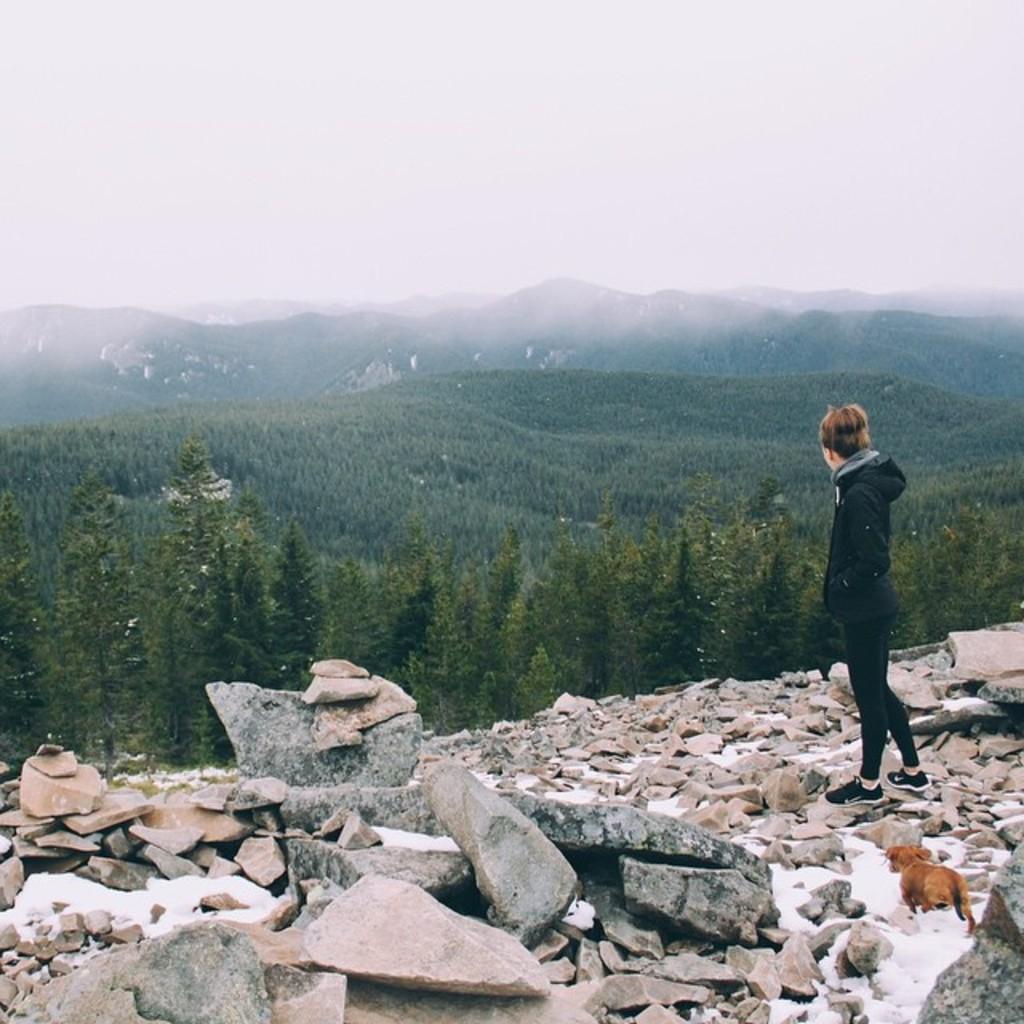In one or two sentences, can you explain what this image depicts? In the image there is a boy standing on the rocks and in the background there are trees and mountains. 